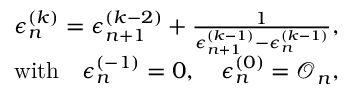<formula> <loc_0><loc_0><loc_500><loc_500>\begin{array} { r l r } & { \epsilon _ { n } ^ { ( k ) } = \epsilon _ { n + 1 } ^ { ( k - 2 ) } + \frac { 1 } { \epsilon _ { n + 1 } ^ { ( k - 1 ) } - \epsilon _ { n } ^ { ( k - 1 ) } } , } \\ & { w i t h \quad \epsilon _ { n } ^ { ( - 1 ) } = 0 , \quad \epsilon _ { n } ^ { ( 0 ) } = \mathcal { O } _ { n } , } \end{array}</formula> 